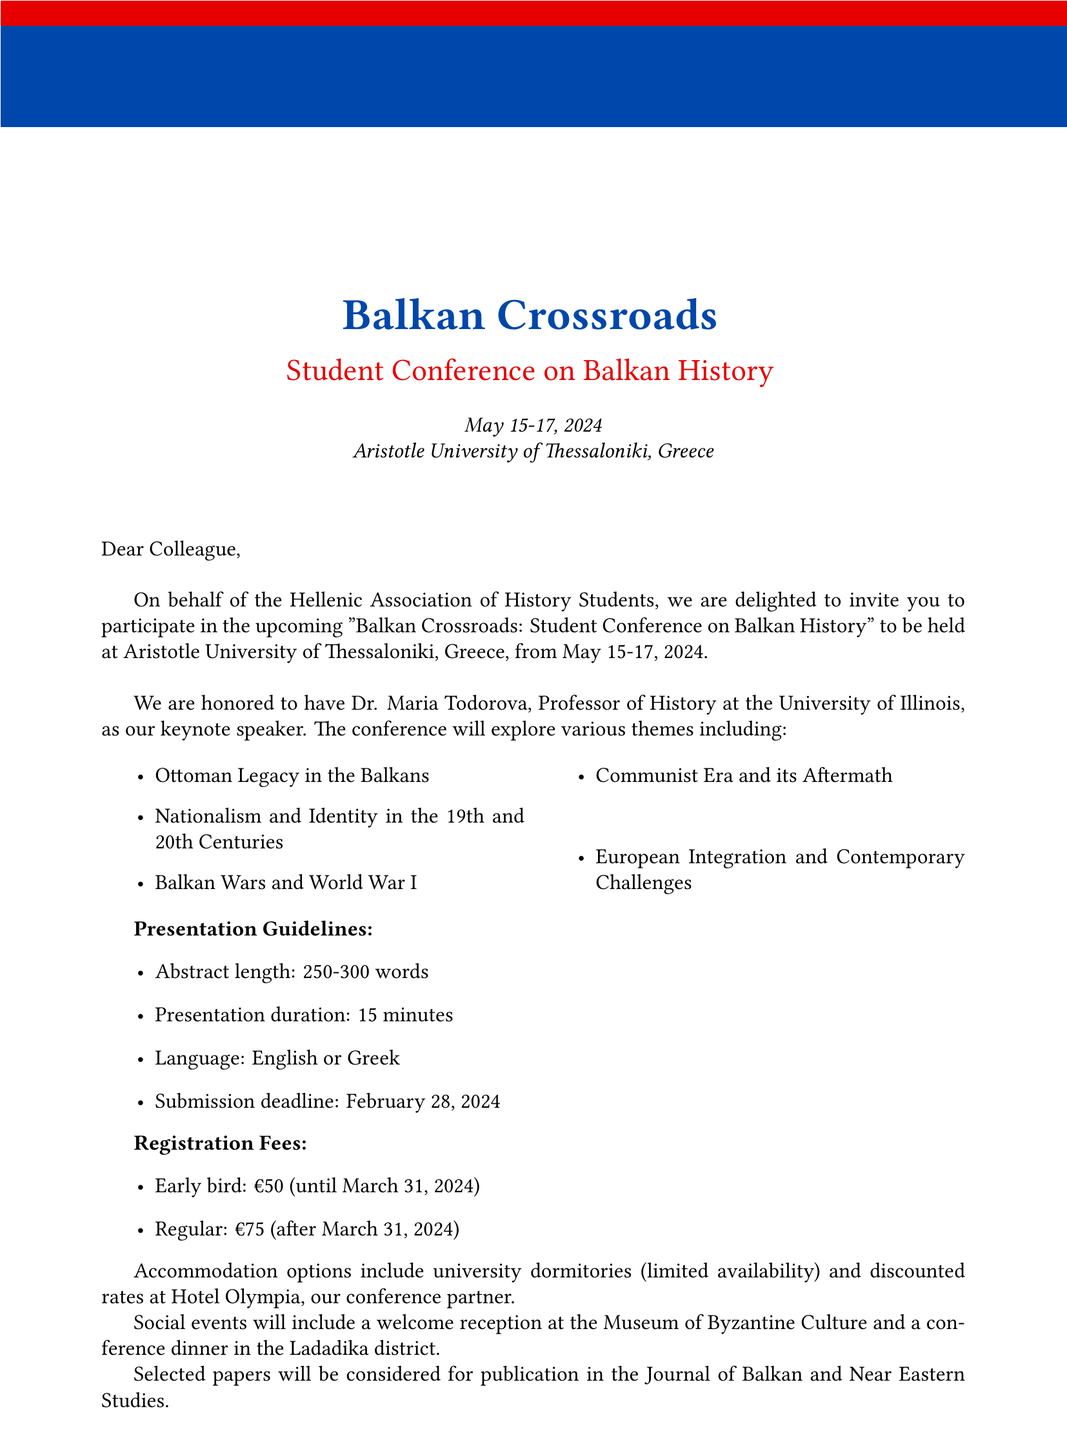What is the event name? The event name is specifically stated at the beginning of the document as "Balkan Crossroads: Student Conference on Balkan History."
Answer: Balkan Crossroads: Student Conference on Balkan History When does the conference take place? The document provides the exact dates for the conference as May 15-17, 2024.
Answer: May 15-17, 2024 Who is the keynote speaker? The document clearly mentions that the keynote speaker is Dr. Maria Todorova, a Professor of History at the University of Illinois.
Answer: Dr. Maria Todorova What is the abstract length for presentations? The document specifies the required abstract length for presentations as 250-300 words.
Answer: 250-300 words What is the registration fee for early birds? The document indicates the early bird registration fee is €50 until March 31, 2024.
Answer: €50 What is the language requirement for presentations? The document states that presentations can be in either English or Greek, which is explicitly mentioned in the guidelines.
Answer: English or Greek How many themes are presented in the conference? The document lists five themes that will be explored at the conference.
Answer: Five What is a special opportunity mentioned for selected papers? The document highlights that selected papers will be considered for publication in the Journal of Balkan and Near Eastern Studies.
Answer: Publication opportunity Who is the contact person for the conference? The document provides the name of the contact person as Dimitris Papadopoulos, the Conference Coordinator.
Answer: Dimitris Papadopoulos 